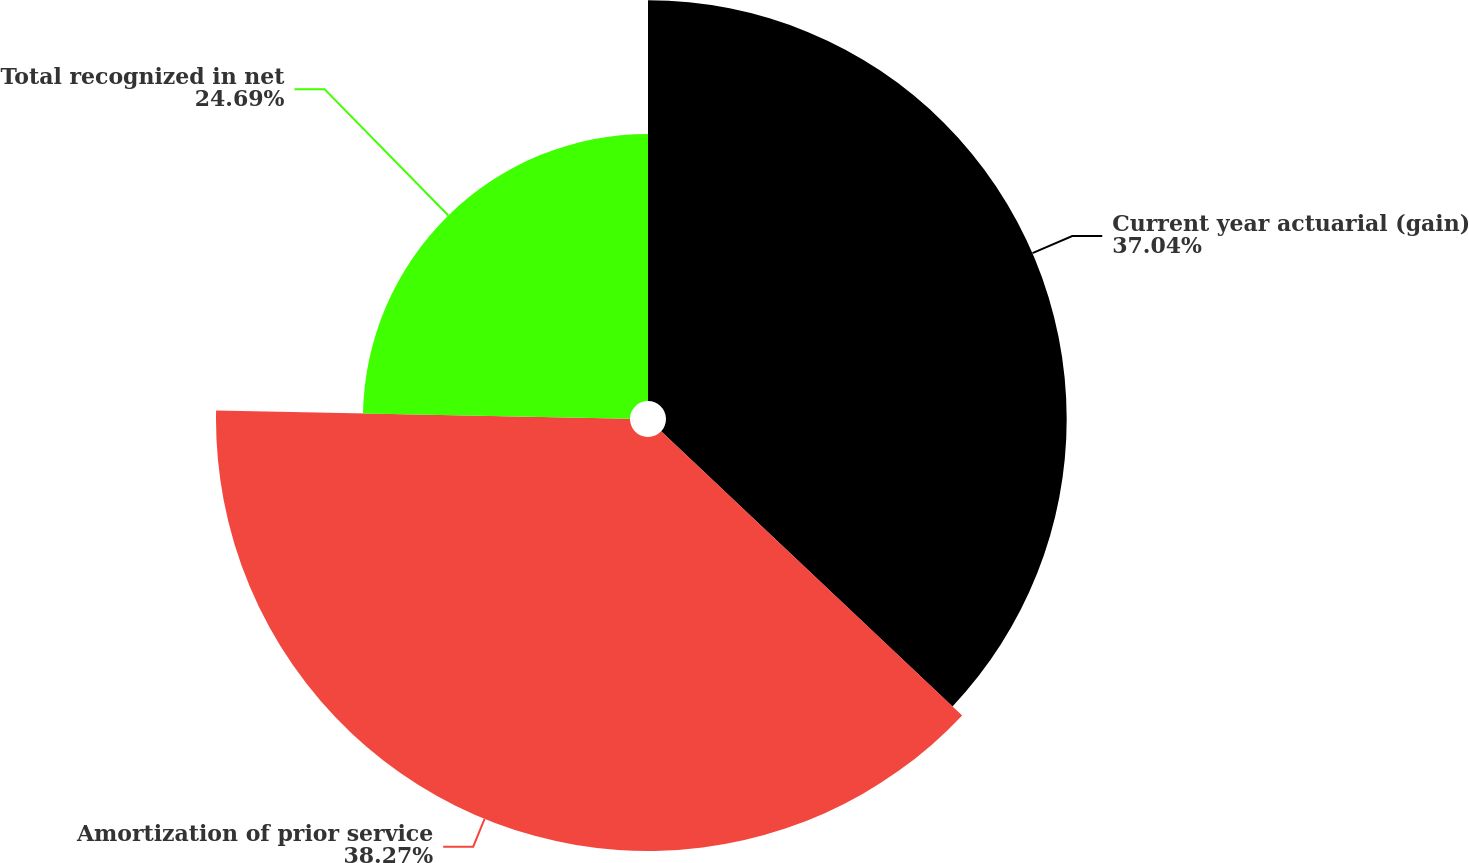Convert chart to OTSL. <chart><loc_0><loc_0><loc_500><loc_500><pie_chart><fcel>Current year actuarial (gain)<fcel>Amortization of prior service<fcel>Total recognized in net<nl><fcel>37.04%<fcel>38.27%<fcel>24.69%<nl></chart> 